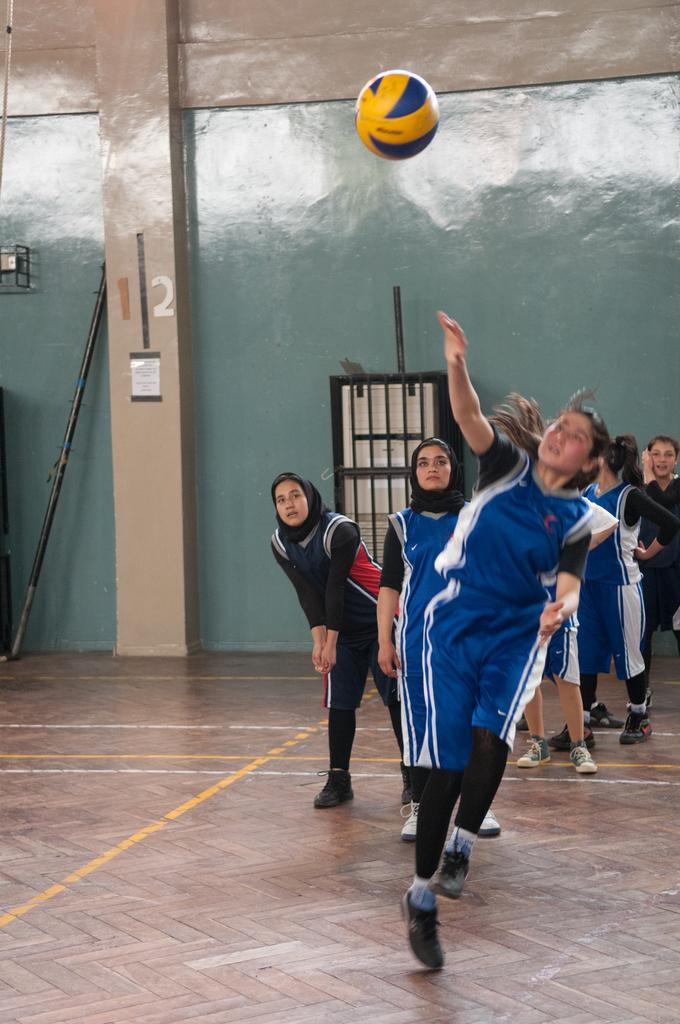What are the girls in the image doing? The girls are standing in a line in the image. What is happening in the air in the image? There is a ball in the air in the image. What can be seen in the background of the image? There is a wall visible in the image. What is the color of the wall in the image? The wall is blue in color. Where is the doll placed in the image? There is no doll present in the image. What type of grape is being used as a prop in the image? There is no grape present in the image. 